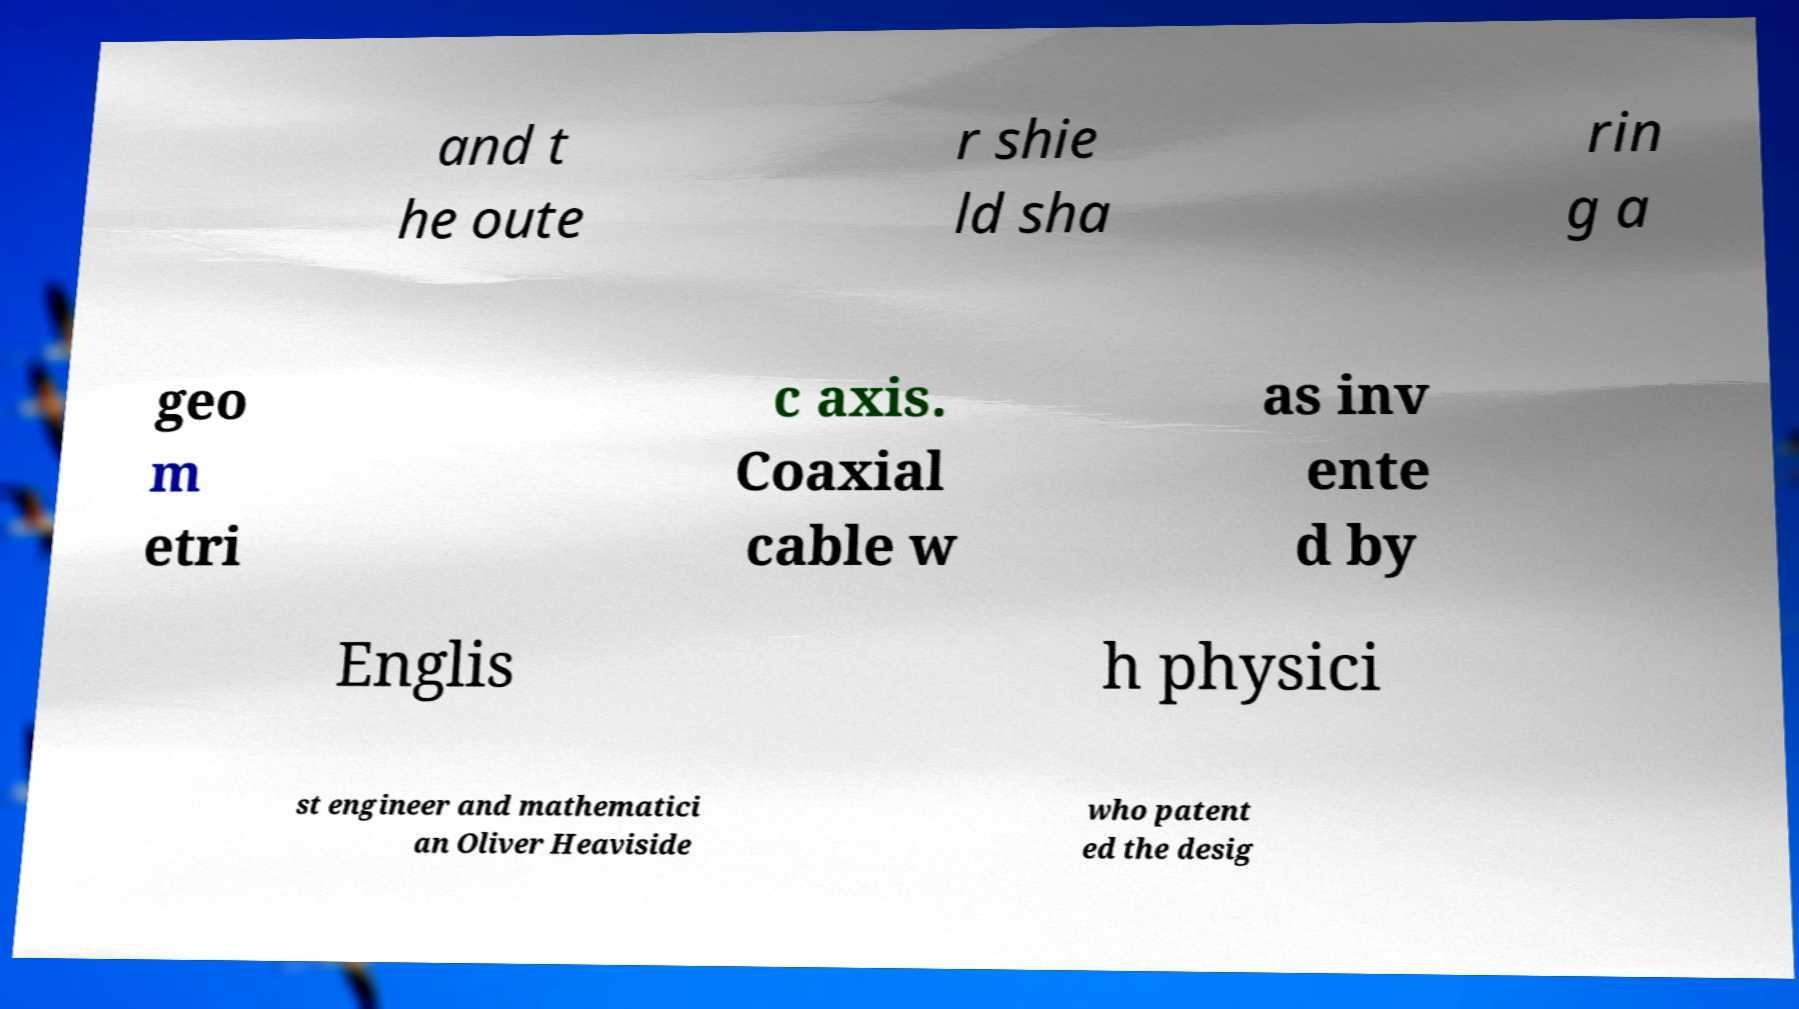Could you extract and type out the text from this image? and t he oute r shie ld sha rin g a geo m etri c axis. Coaxial cable w as inv ente d by Englis h physici st engineer and mathematici an Oliver Heaviside who patent ed the desig 